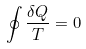Convert formula to latex. <formula><loc_0><loc_0><loc_500><loc_500>\oint { \frac { \delta Q } { T } } = 0</formula> 